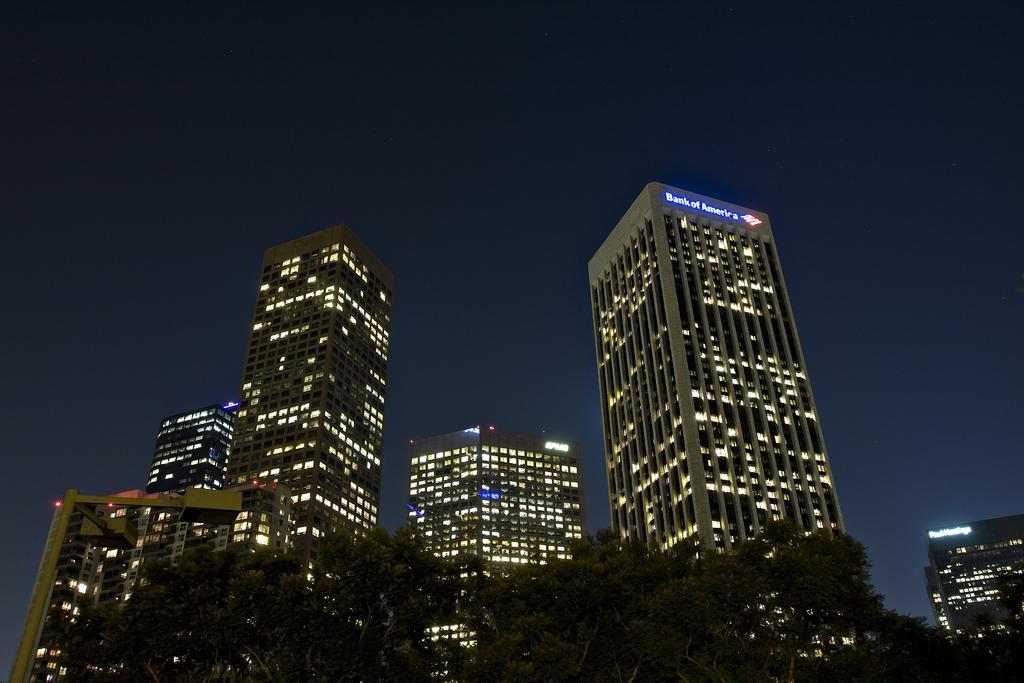Describe this image in one or two sentences. In this picture we can see few trees, buildings and lights. 